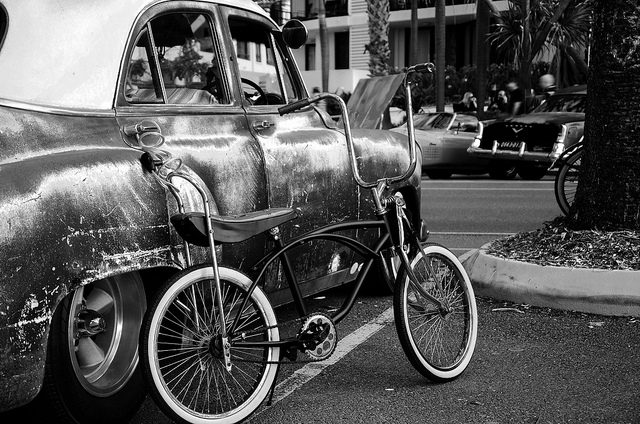What era does the car in the photo appear to be from? The car has a vintage design that suggests it's from the mid-20th century, possibly the 1950s or 1960s, characterized by its rounded body shape and chrome finish. 